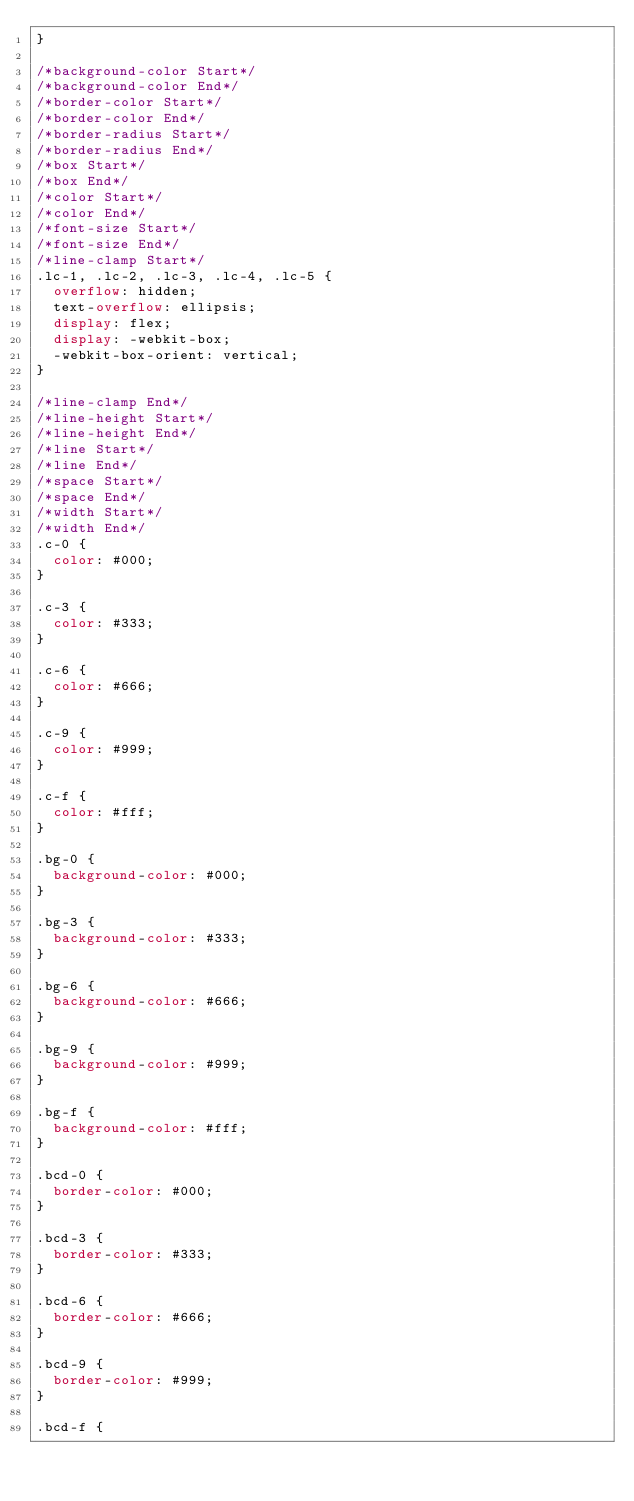<code> <loc_0><loc_0><loc_500><loc_500><_CSS_>}

/*background-color Start*/
/*background-color End*/
/*border-color Start*/
/*border-color End*/
/*border-radius Start*/
/*border-radius End*/
/*box Start*/
/*box End*/
/*color Start*/
/*color End*/
/*font-size Start*/
/*font-size End*/
/*line-clamp Start*/
.lc-1, .lc-2, .lc-3, .lc-4, .lc-5 {
  overflow: hidden;
  text-overflow: ellipsis;
  display: flex;
  display: -webkit-box;
  -webkit-box-orient: vertical;
}

/*line-clamp End*/
/*line-height Start*/
/*line-height End*/
/*line Start*/
/*line End*/
/*space Start*/
/*space End*/
/*width Start*/
/*width End*/
.c-0 {
  color: #000;
}

.c-3 {
  color: #333;
}

.c-6 {
  color: #666;
}

.c-9 {
  color: #999;
}

.c-f {
  color: #fff;
}

.bg-0 {
  background-color: #000;
}

.bg-3 {
  background-color: #333;
}

.bg-6 {
  background-color: #666;
}

.bg-9 {
  background-color: #999;
}

.bg-f {
  background-color: #fff;
}

.bcd-0 {
  border-color: #000;
}

.bcd-3 {
  border-color: #333;
}

.bcd-6 {
  border-color: #666;
}

.bcd-9 {
  border-color: #999;
}

.bcd-f {</code> 